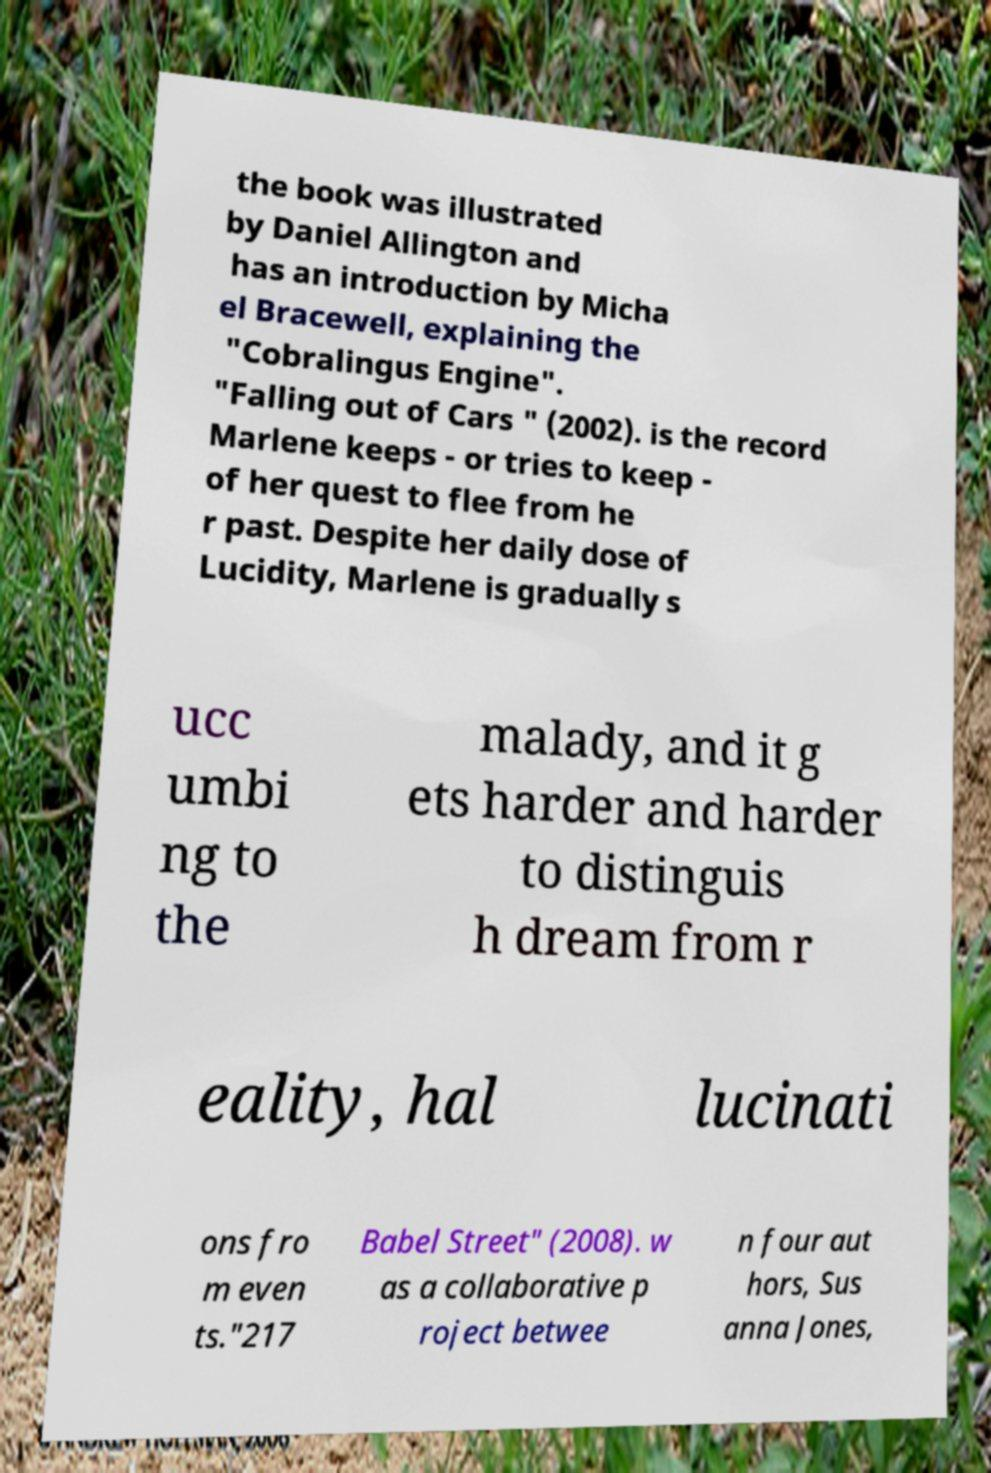Please read and relay the text visible in this image. What does it say? the book was illustrated by Daniel Allington and has an introduction by Micha el Bracewell, explaining the "Cobralingus Engine". "Falling out of Cars " (2002). is the record Marlene keeps - or tries to keep - of her quest to flee from he r past. Despite her daily dose of Lucidity, Marlene is gradually s ucc umbi ng to the malady, and it g ets harder and harder to distinguis h dream from r eality, hal lucinati ons fro m even ts."217 Babel Street" (2008). w as a collaborative p roject betwee n four aut hors, Sus anna Jones, 